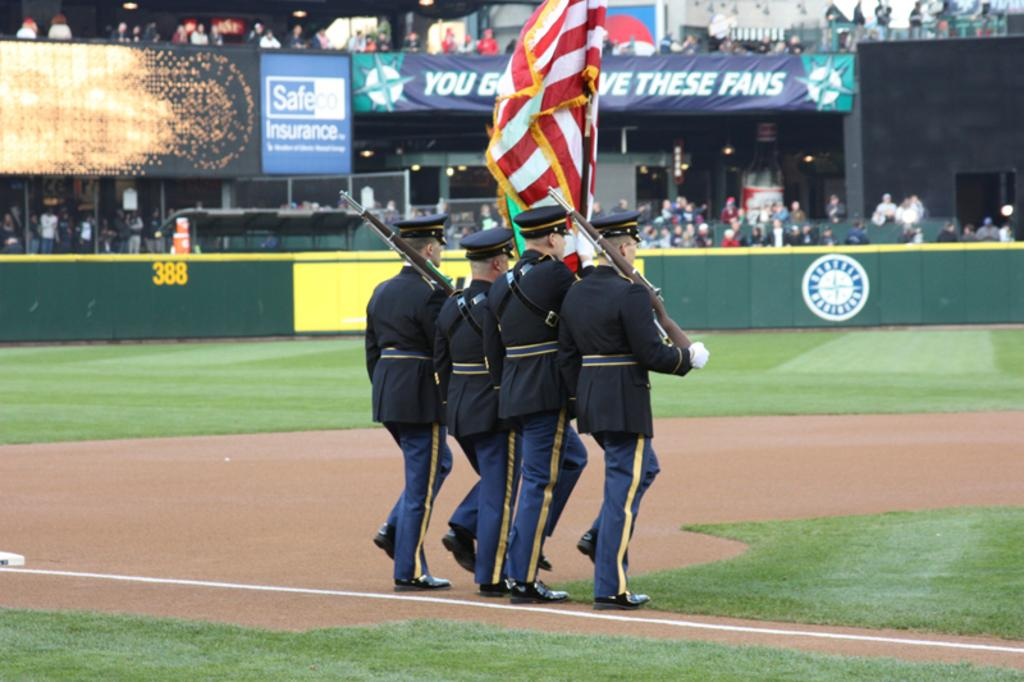<image>
Relay a brief, clear account of the picture shown. A Safeco Insurance ad is on the light-up sign display. 